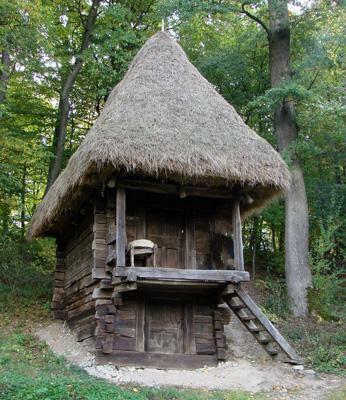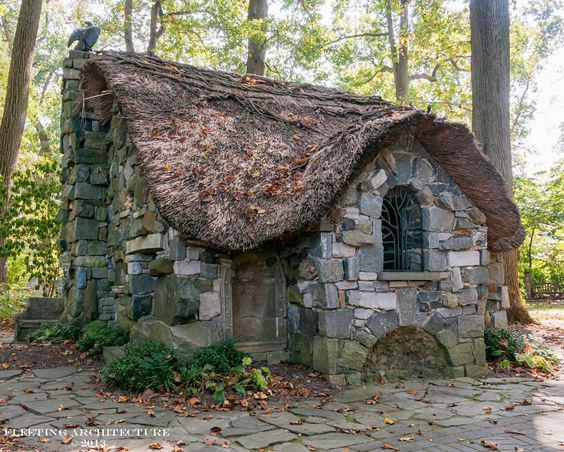The first image is the image on the left, the second image is the image on the right. Evaluate the accuracy of this statement regarding the images: "An outdoor ladder leads up to a structure in one of the images.". Is it true? Answer yes or no. Yes. The first image is the image on the left, the second image is the image on the right. For the images shown, is this caption "On image shows stairs ascending rightward to a deck on an elevated structure with a peaked pyramid-shaped roof." true? Answer yes or no. Yes. 